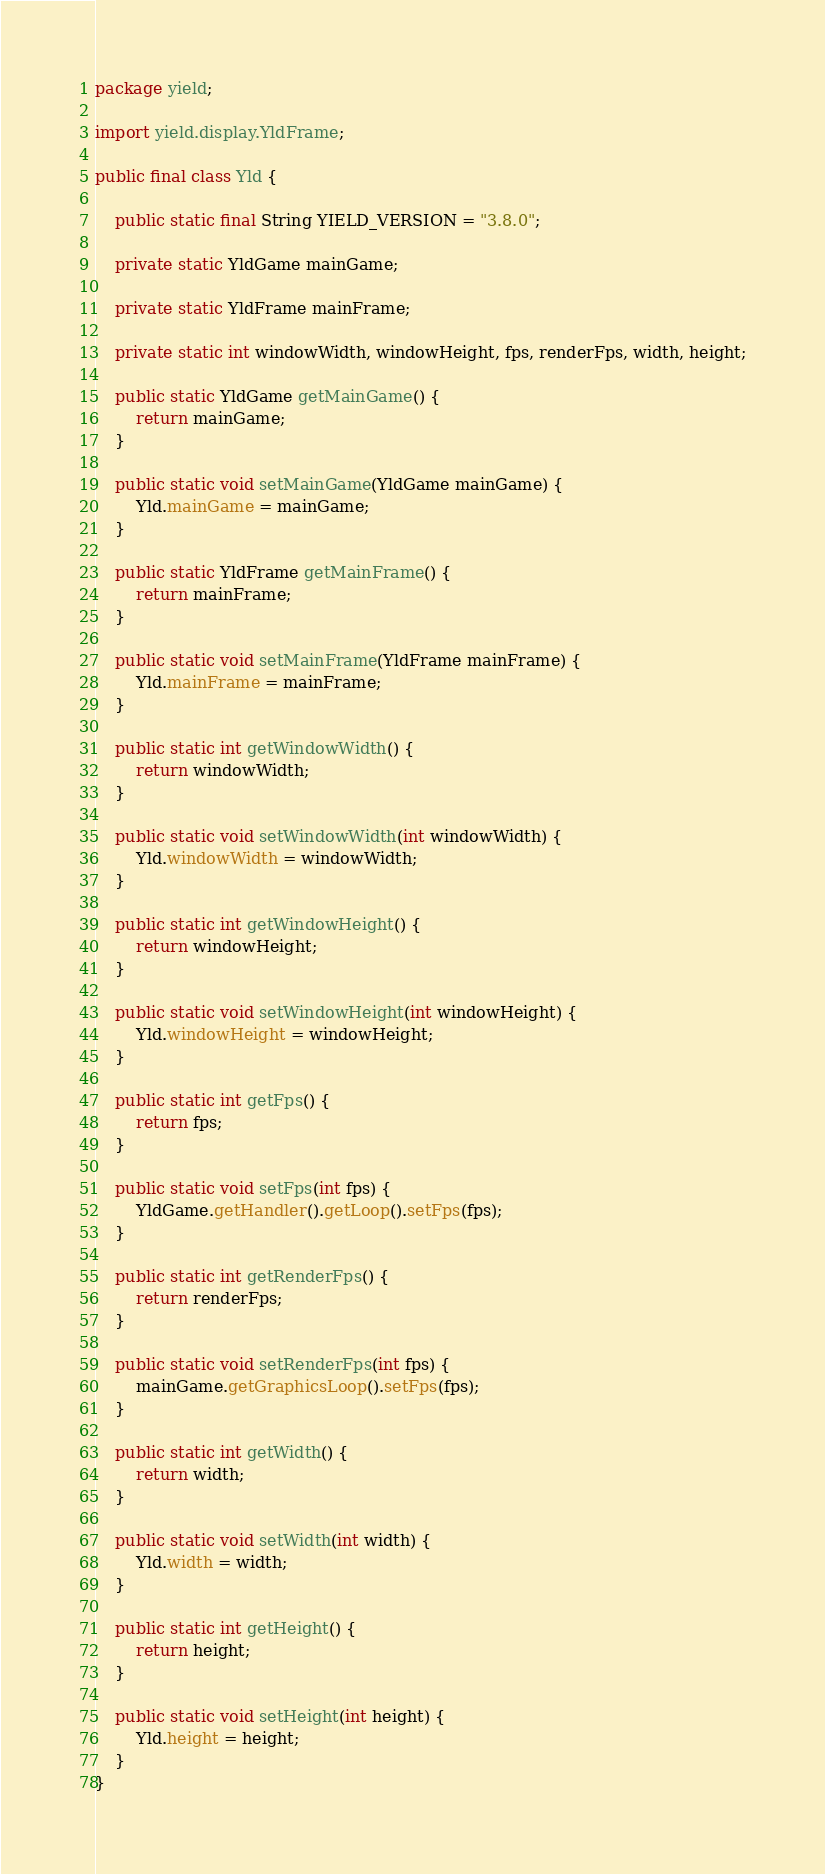<code> <loc_0><loc_0><loc_500><loc_500><_Java_>package yield;

import yield.display.YldFrame;

public final class Yld {

    public static final String YIELD_VERSION = "3.8.0";

    private static YldGame mainGame;

    private static YldFrame mainFrame;

    private static int windowWidth, windowHeight, fps, renderFps, width, height;

    public static YldGame getMainGame() {
        return mainGame;
    }

    public static void setMainGame(YldGame mainGame) {
        Yld.mainGame = mainGame;
    }

    public static YldFrame getMainFrame() {
        return mainFrame;
    }

    public static void setMainFrame(YldFrame mainFrame) {
        Yld.mainFrame = mainFrame;
    }

    public static int getWindowWidth() {
        return windowWidth;
    }

    public static void setWindowWidth(int windowWidth) {
        Yld.windowWidth = windowWidth;
    }

    public static int getWindowHeight() {
        return windowHeight;
    }

    public static void setWindowHeight(int windowHeight) {
        Yld.windowHeight = windowHeight;
    }

    public static int getFps() {
        return fps;
    }

    public static void setFps(int fps) {
        YldGame.getHandler().getLoop().setFps(fps);
    }

    public static int getRenderFps() {
        return renderFps;
    }

    public static void setRenderFps(int fps) {
        mainGame.getGraphicsLoop().setFps(fps);
    }

    public static int getWidth() {
        return width;
    }

    public static void setWidth(int width) {
        Yld.width = width;
    }

    public static int getHeight() {
        return height;
    }

    public static void setHeight(int height) {
        Yld.height = height;
    }
}
</code> 